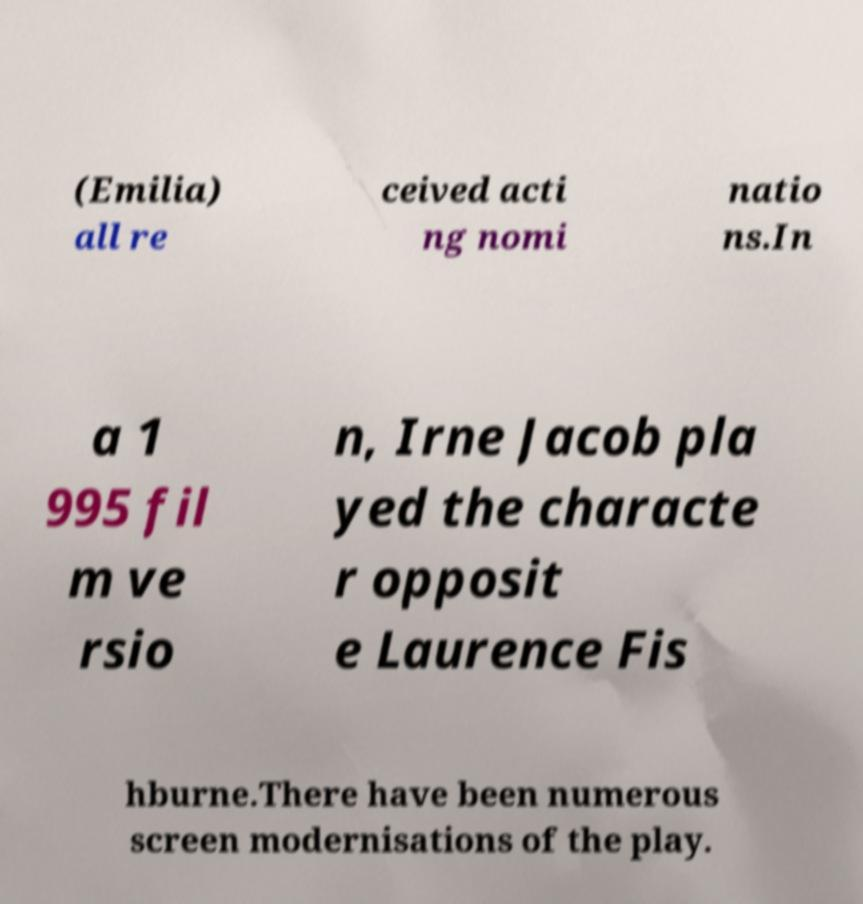Please identify and transcribe the text found in this image. (Emilia) all re ceived acti ng nomi natio ns.In a 1 995 fil m ve rsio n, Irne Jacob pla yed the characte r opposit e Laurence Fis hburne.There have been numerous screen modernisations of the play. 